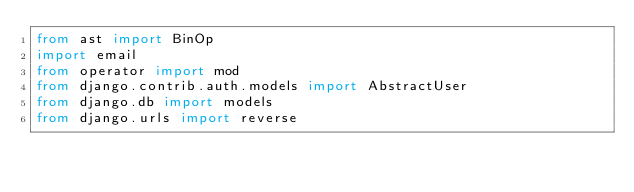Convert code to text. <code><loc_0><loc_0><loc_500><loc_500><_Python_>from ast import BinOp
import email
from operator import mod
from django.contrib.auth.models import AbstractUser
from django.db import models
from django.urls import reverse</code> 